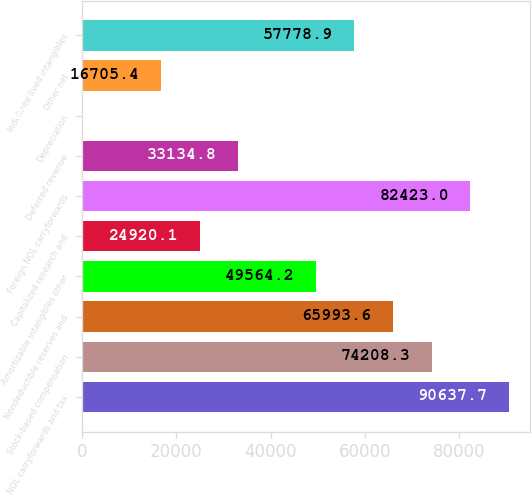Convert chart. <chart><loc_0><loc_0><loc_500><loc_500><bar_chart><fcel>NOL carryforwards and tax<fcel>Stock-based compensation<fcel>Nondeductible reserves and<fcel>Amortizable intangibles other<fcel>Capitalized research and<fcel>Foreign NOL carryforwards<fcel>Deferred revenue<fcel>Depreciation<fcel>Other net<fcel>Indefinite lived intangibles<nl><fcel>90637.7<fcel>74208.3<fcel>65993.6<fcel>49564.2<fcel>24920.1<fcel>82423<fcel>33134.8<fcel>276<fcel>16705.4<fcel>57778.9<nl></chart> 